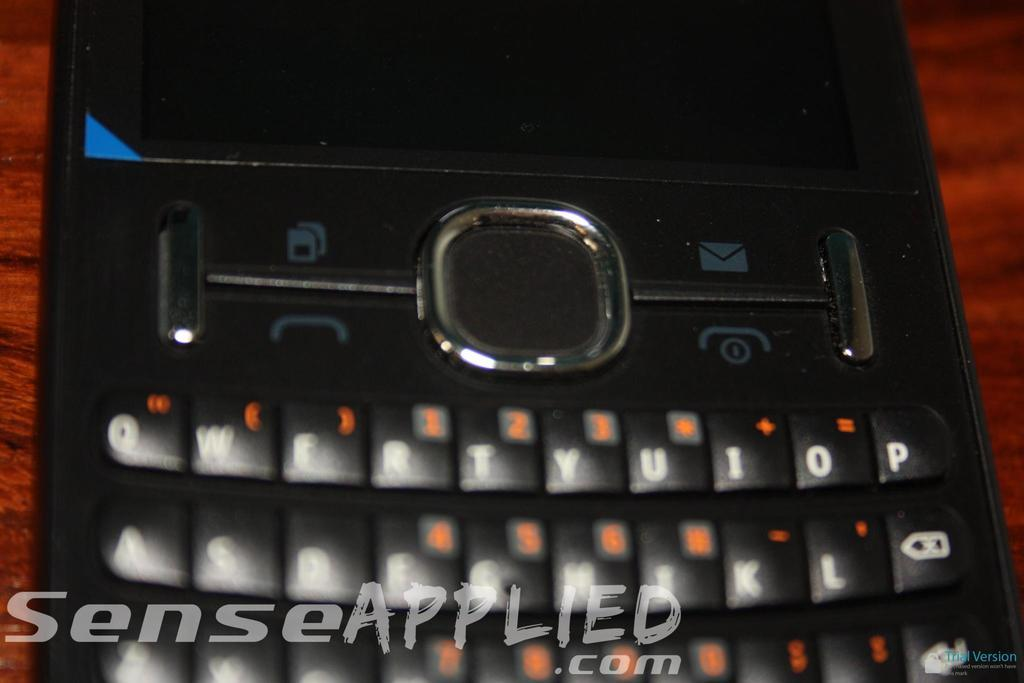Provide a one-sentence caption for the provided image. SenseApplied.com in the foreground and a cell phone on a maroon table. 